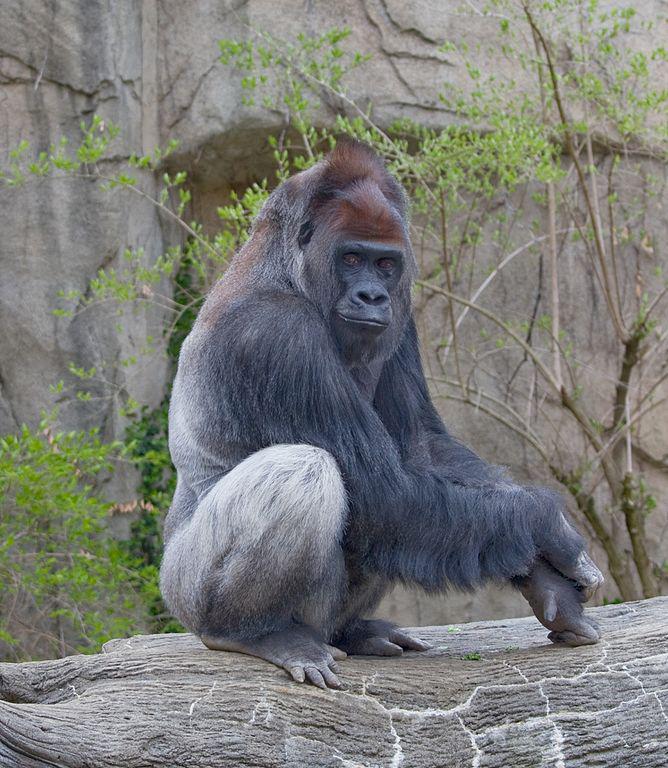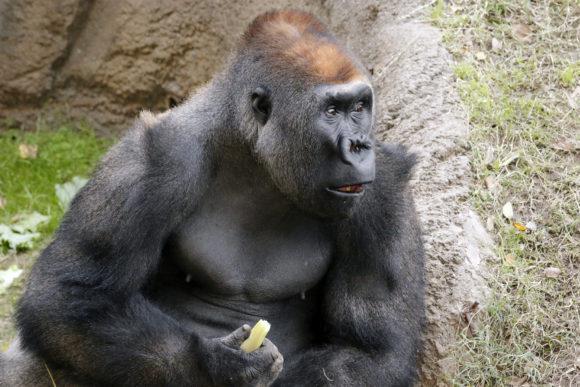The first image is the image on the left, the second image is the image on the right. Analyze the images presented: Is the assertion "An image shows one forward-turned gorilla standing in a small blue pool splashing water and posed with both arms outstretched horizontally." valid? Answer yes or no. No. 